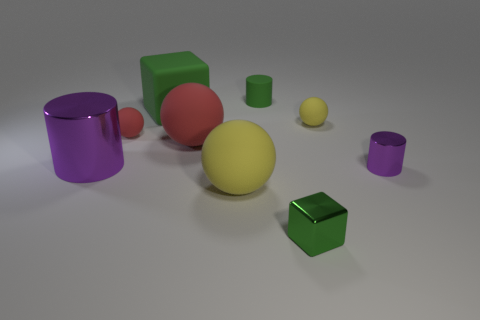Subtract all tiny red balls. How many balls are left? 3 Add 1 big red metallic balls. How many objects exist? 10 Subtract 0 yellow cylinders. How many objects are left? 9 Subtract all blocks. How many objects are left? 7 Subtract 3 cylinders. How many cylinders are left? 0 Subtract all cyan cylinders. Subtract all brown spheres. How many cylinders are left? 3 Subtract all blue balls. How many purple blocks are left? 0 Subtract all tiny green objects. Subtract all large things. How many objects are left? 3 Add 5 rubber cylinders. How many rubber cylinders are left? 6 Add 3 tiny blue spheres. How many tiny blue spheres exist? 3 